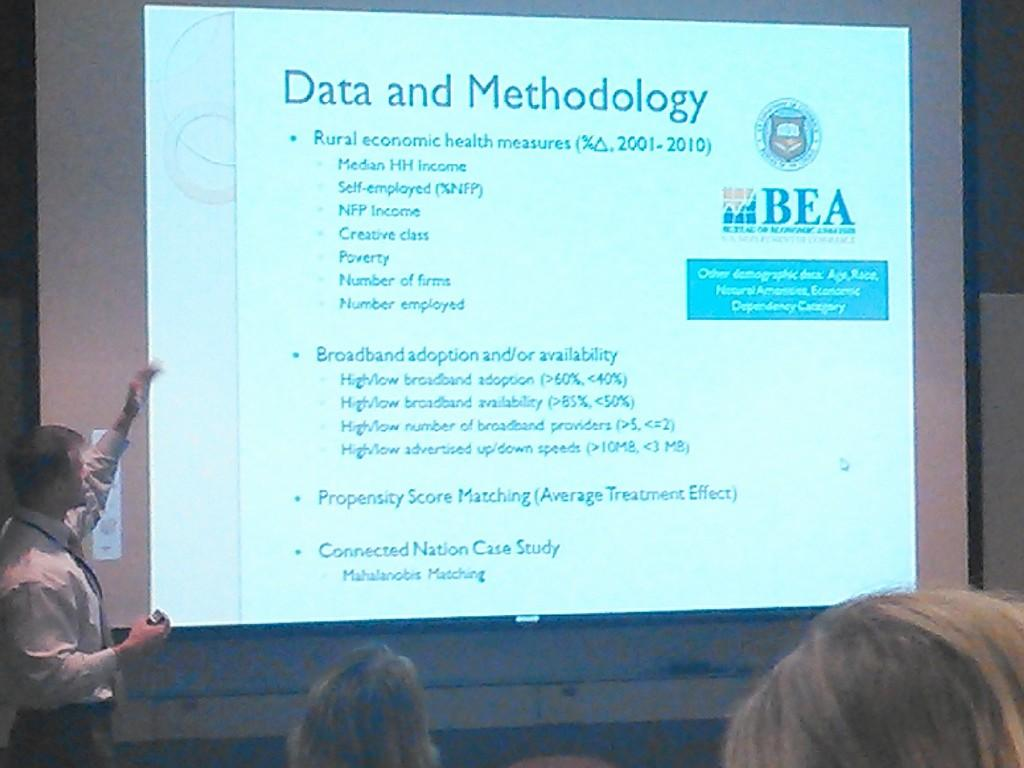How many people are in the image? There are two persons in the image. What can be seen in the image besides the people? There is a screen in the image. What is the person behind the screen doing? The person behind the screen is holding an object. What is the position of the moon in the image? There is no moon present in the image. 